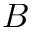<formula> <loc_0><loc_0><loc_500><loc_500>B</formula> 